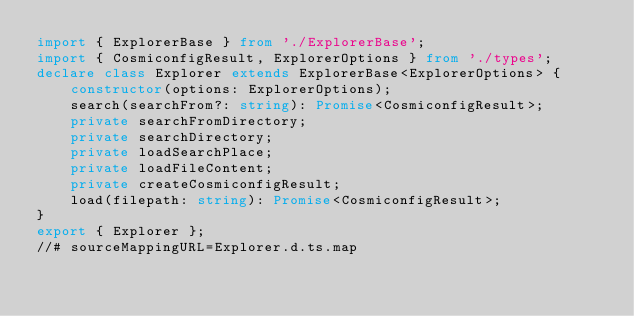<code> <loc_0><loc_0><loc_500><loc_500><_TypeScript_>import { ExplorerBase } from './ExplorerBase';
import { CosmiconfigResult, ExplorerOptions } from './types';
declare class Explorer extends ExplorerBase<ExplorerOptions> {
    constructor(options: ExplorerOptions);
    search(searchFrom?: string): Promise<CosmiconfigResult>;
    private searchFromDirectory;
    private searchDirectory;
    private loadSearchPlace;
    private loadFileContent;
    private createCosmiconfigResult;
    load(filepath: string): Promise<CosmiconfigResult>;
}
export { Explorer };
//# sourceMappingURL=Explorer.d.ts.map</code> 